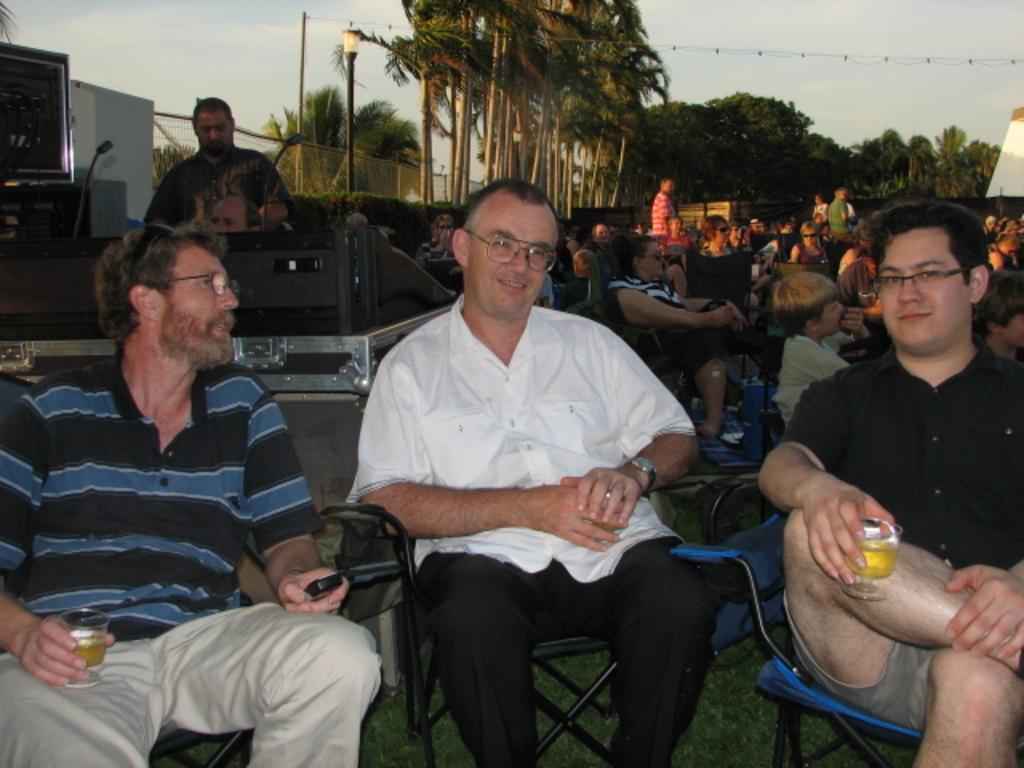Can you describe this image briefly? There are people sitting on chairs and few people standing. We can see objects and microphones on the table and we can see television. In the background we can see fence, poles, lights, plants, wire with lights, trees and sky. 